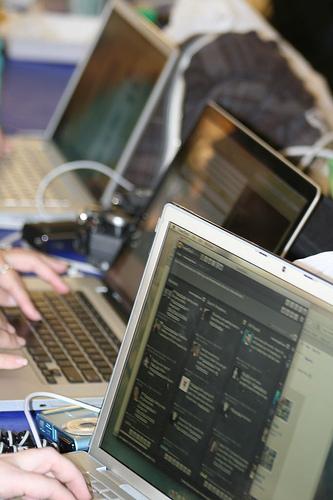Where would this person look first to tell time?
Give a very brief answer. Screen. How many computers are there?
Keep it brief. 3. Are the computer monitors turned on?
Keep it brief. Yes. How many hands are visible?
Give a very brief answer. 3. 